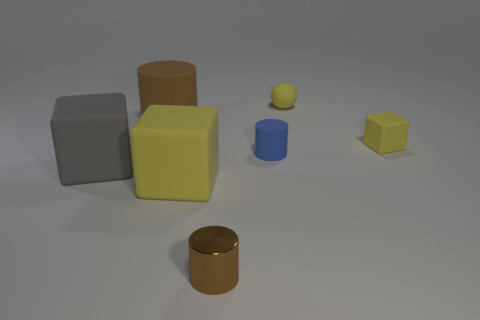What materials do the objects in the image appear to be made from? The objects in the image seem to be made from different materials. The cylinders and cubes likely represent metal and plastic materials, as suggested by their reflective and matte surfaces respectively. 